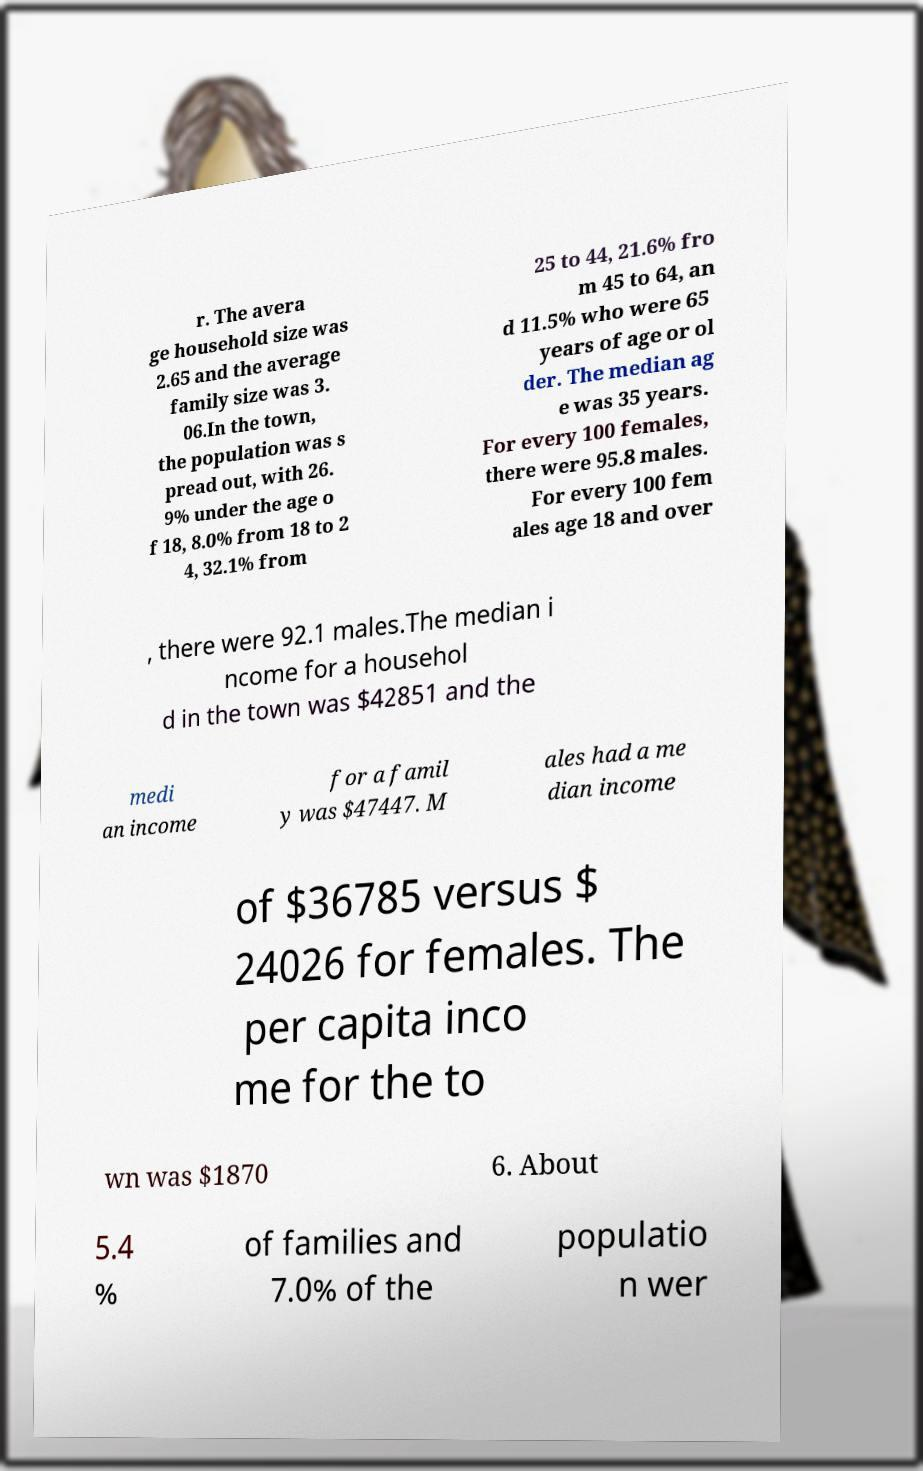Could you extract and type out the text from this image? r. The avera ge household size was 2.65 and the average family size was 3. 06.In the town, the population was s pread out, with 26. 9% under the age o f 18, 8.0% from 18 to 2 4, 32.1% from 25 to 44, 21.6% fro m 45 to 64, an d 11.5% who were 65 years of age or ol der. The median ag e was 35 years. For every 100 females, there were 95.8 males. For every 100 fem ales age 18 and over , there were 92.1 males.The median i ncome for a househol d in the town was $42851 and the medi an income for a famil y was $47447. M ales had a me dian income of $36785 versus $ 24026 for females. The per capita inco me for the to wn was $1870 6. About 5.4 % of families and 7.0% of the populatio n wer 